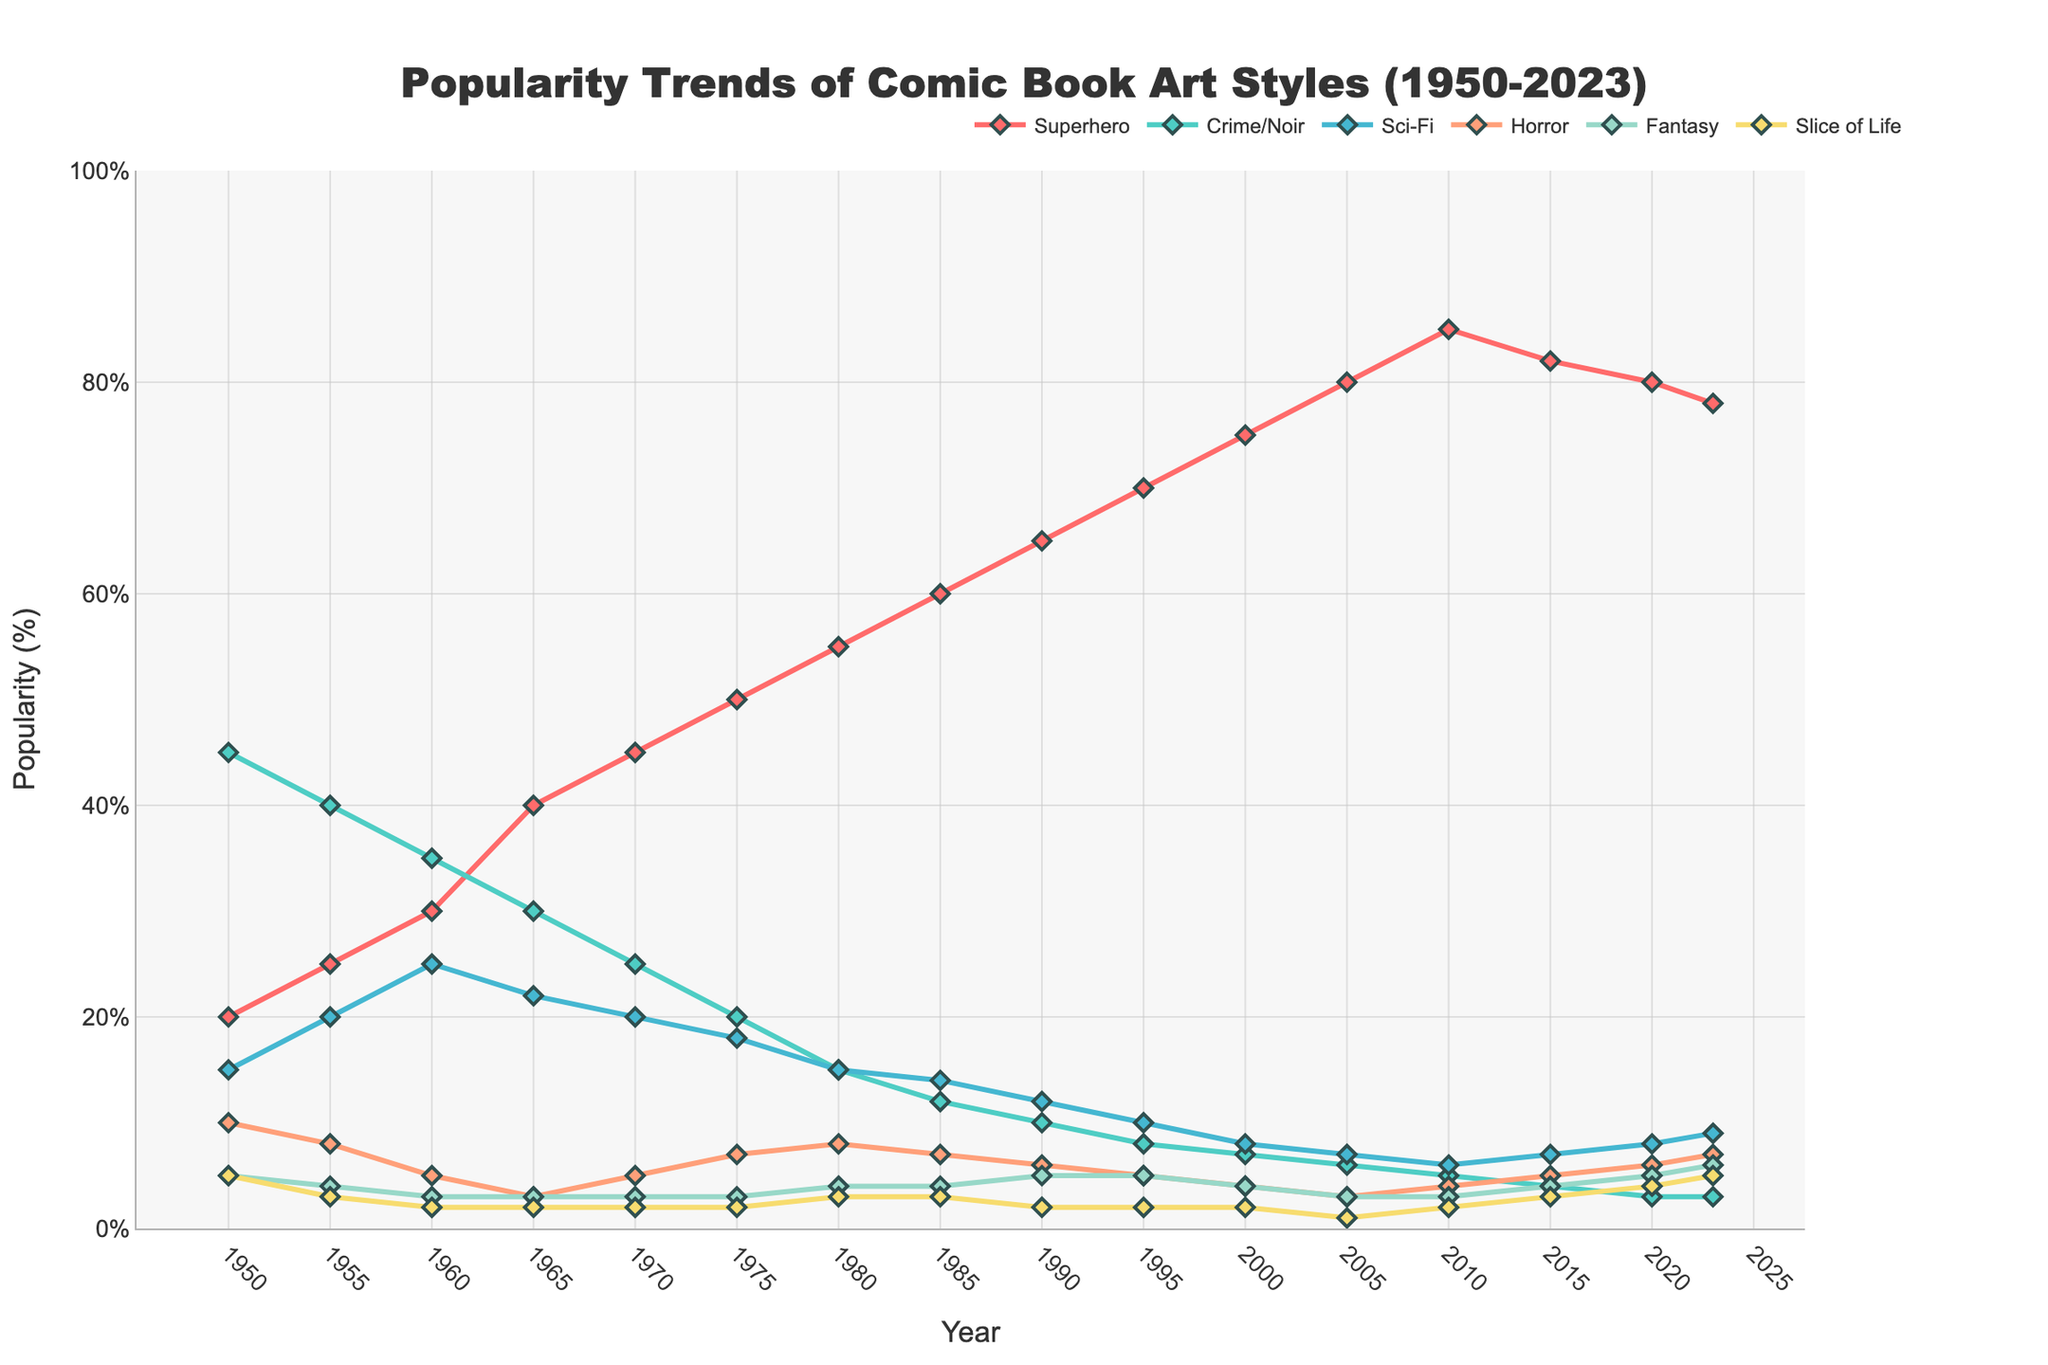What genre saw the most significant increase in popularity from 1950 to 2023? Look at the beginning and ending values of each genre's trend line. Calculate the increase by subtracting the initial value from the final value for each genre and compare the results. Superhero genre increased from 20% to 78%, which is an increase of 58%.
Answer: Superhero Which genre had the highest popularity in the year 2000? Check the y-values for all genres at the year 2000. The Superhero genre has the highest value of 75%.
Answer: Superhero By how much did the popularity of the Crime/Noir genre decrease from 1950 to 2023? Find the popularity of Crime/Noir in 1950 (45%) and subtract the value in 2023 (3%). 45% - 3% = 42%.
Answer: 42% Compare the popularity trends of Sci-Fi and Horror genres in the year 2020. Which was more popular and by what percentage difference? Look at the data points for Sci-Fi (8%) and Horror (6%) in 2020. Subtract the lower value from the higher value: 8% - 6% = 2%. Sci-Fi was more popular by 2%.
Answer: Sci-Fi by 2% Between which two consecutive years did the Fantasy genre show the most substantial increase? Calculate the difference in popularity for the Fantasy genre between each pair of consecutive years and identify the maximum increase. The biggest jump occurs between 2020 (5%) and 2023 (6%), which is 1%.
Answer: 2020-2023 What is the average popularity of the Slice of Life genre over the entire period (1950-2023)? Sum all the values of the Slice of Life genre: 5+3+2+2+2+2+3+3+2+2+2+1+2+3+4+5. Sum = 43. Divide this by the number of years: 43 / 16 = 2.6875.
Answer: 2.69 Which genre had a steady decline in popularity from 1950 to 2023? Examine the trend lines to see which genre consistently decreases without significant rises. Crime/Noir appears to have a steady decline from 45% to 3%.
Answer: Crime/Noir In what year did the Superhero genre first reach 50% popularity? Go through the data points for the Superhero genre to find the year where it first meets or exceeds 50%. It occurred in 1975.
Answer: 1975 How does the popularity of the Horror genre in 1980 compare to that in 2023? Check the y-values of the Horror genre in 1980 (8%) and 2023 (7%). The popularity in 1980 was slightly higher by 1%.
Answer: 1980 is higher by 1% 